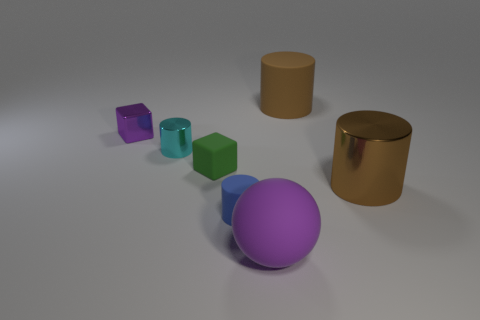Add 1 cubes. How many objects exist? 8 Subtract all blocks. How many objects are left? 5 Add 4 cyan shiny things. How many cyan shiny things are left? 5 Add 1 tiny green cubes. How many tiny green cubes exist? 2 Subtract 1 purple blocks. How many objects are left? 6 Subtract all blue matte cylinders. Subtract all tiny purple metallic cubes. How many objects are left? 5 